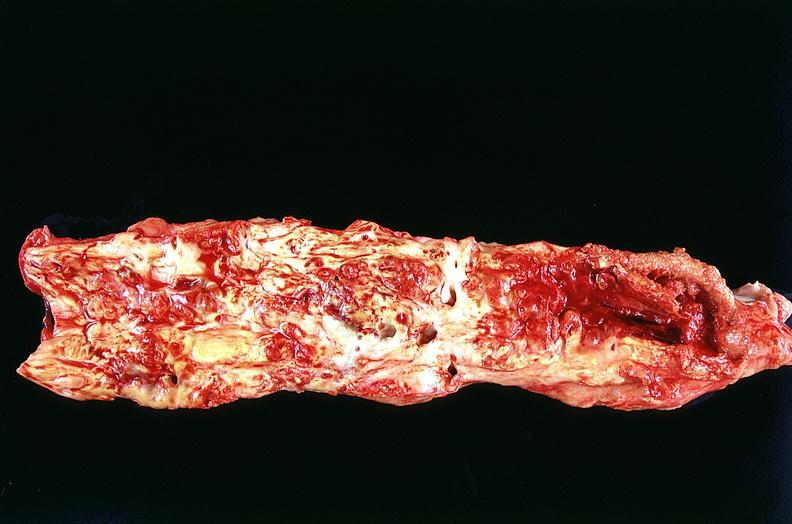what is present?
Answer the question using a single word or phrase. Cardiovascular 